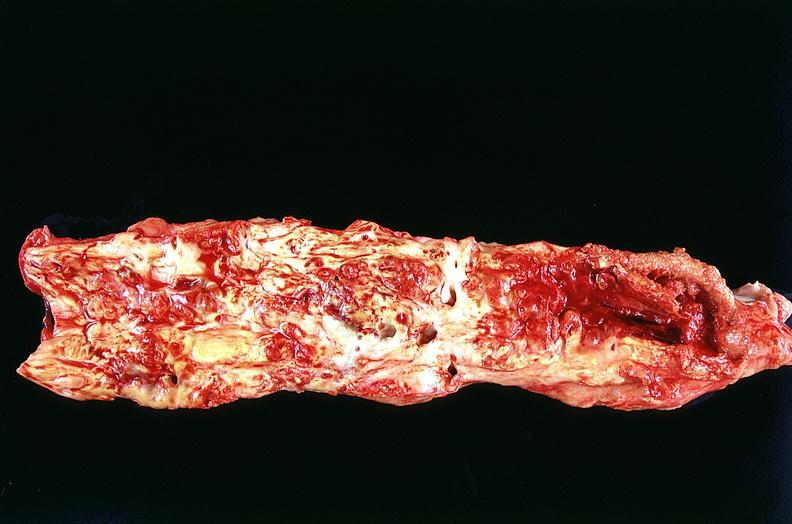what is present?
Answer the question using a single word or phrase. Cardiovascular 